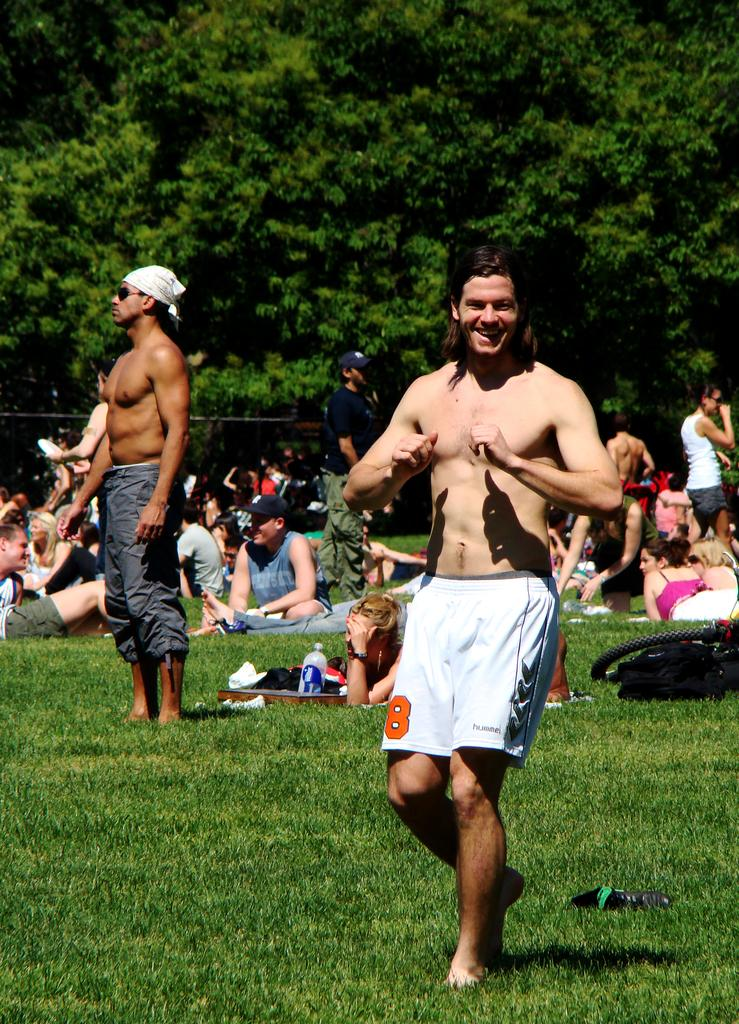<image>
Present a compact description of the photo's key features. Man wearing nothing but white shorts with a number 8 on it. 